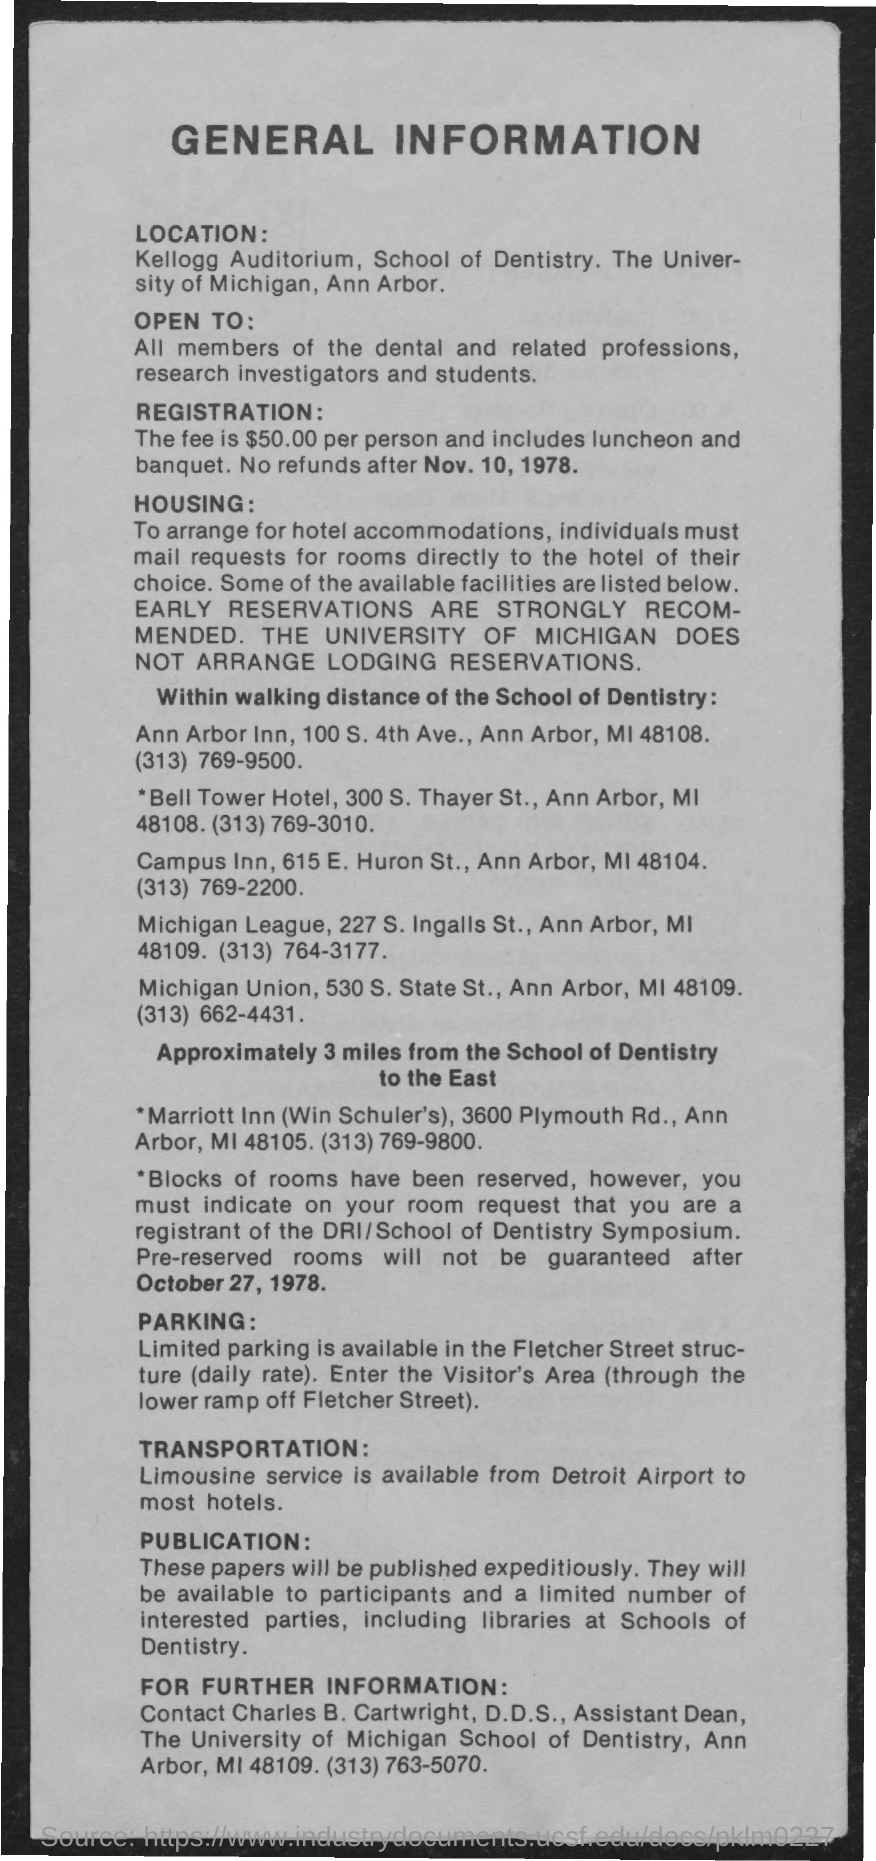Who is the assitant dean at the university of michigan school of dentistry ?
Provide a succinct answer. Charles b. cartwright. Which auditorium is mentioned in the loaction details ?
Your response must be concise. Kellogg auditorium. What is the registration fee per person ?
Your answer should be very brief. $50.00. Where is parking available in ?
Provide a succinct answer. Fletcher Street Structure. Which service is available for transportation ?
Your response must be concise. Limousine service. 